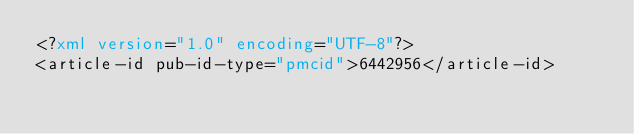<code> <loc_0><loc_0><loc_500><loc_500><_XML_><?xml version="1.0" encoding="UTF-8"?>
<article-id pub-id-type="pmcid">6442956</article-id>
</code> 